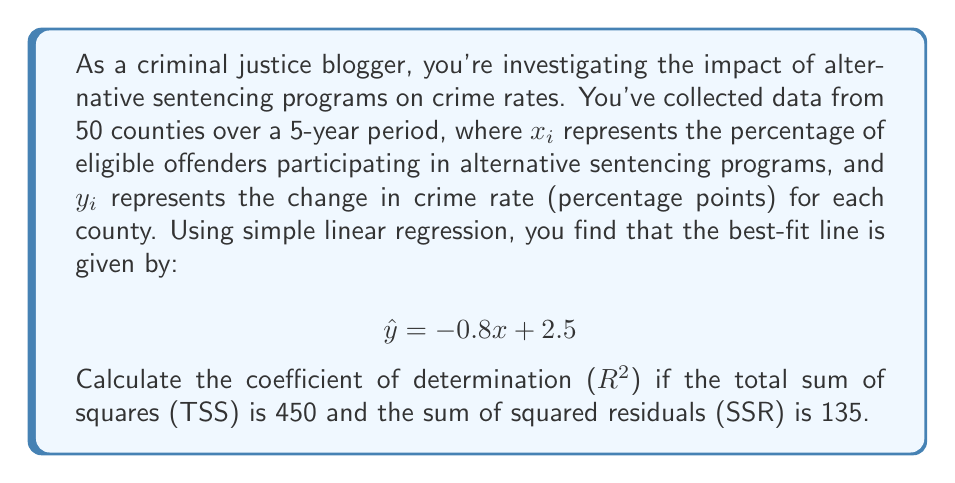Teach me how to tackle this problem. To calculate the coefficient of determination ($R^2$), we need to understand its definition and the components involved:

1) $R^2$ measures the proportion of variance in the dependent variable (change in crime rate) that is predictable from the independent variable (participation in alternative sentencing).

2) It is calculated using the formula:

   $$R^2 = 1 - \frac{SSR}{TSS}$$

   Where:
   - SSR is the sum of squared residuals
   - TSS is the total sum of squares

3) We are given:
   - TSS = 450
   - SSR = 135

4) Substituting these values into the formula:

   $$R^2 = 1 - \frac{135}{450}$$

5) Simplifying:

   $$R^2 = 1 - 0.3 = 0.7$$

6) Therefore, the coefficient of determination is 0.7 or 70%.

This result suggests that 70% of the variability in the change in crime rates can be explained by the percentage of offenders participating in alternative sentencing programs. This indicates a relatively strong relationship between alternative sentencing and crime rate reduction, which could be valuable information for your blog on the benefits of alternative sentencing.
Answer: $R^2 = 0.7$ or 70% 